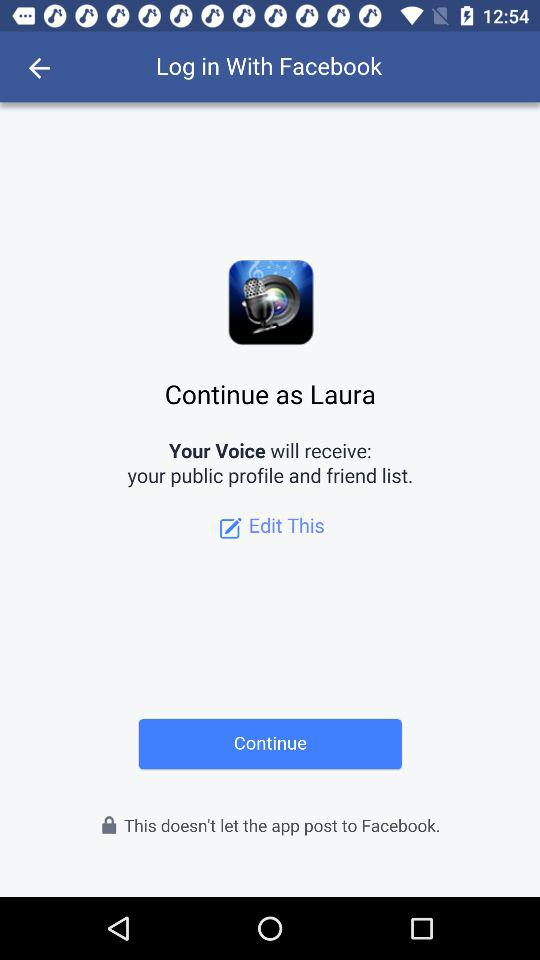What application will receive the public profile and friend list? The public profile and friend list will be received by "Your Voice". 